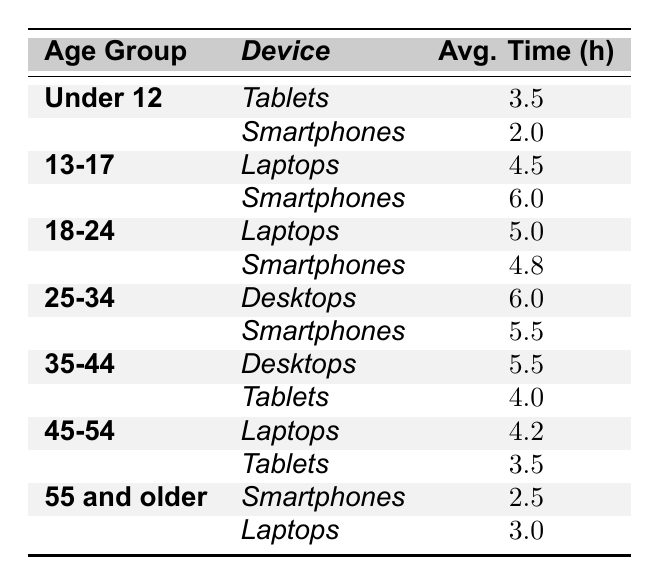What is the average daily screen time for users aged 25-34 using smartphones? The table lists the average daily screen time for the age group 25-34 using smartphones as 5.5 hours.
Answer: 5.5 Which age group has the highest average daily screen time using laptops? According to the table, the age group of 13-17 has the highest average daily screen time using laptops at 4.5 hours.
Answer: 4.5 What is the total average daily screen time for the age group 55 and older across all devices? Adding the values from the 55 and older age group: 2.5 hours (smartphones) + 3.0 hours (laptops) = 5.5 hours.
Answer: 5.5 Is the average daily screen time for tablets among users aged 45-54 greater than that for smartphones? The average daily screen time for tablets among users aged 45-54 is 3.5 hours, while smartphones are not listed for that age group, making this comparison not applicable or undetermined.
Answer: No What is the difference in average daily screen time between the age groups 13-17 and 18-24 for smartphones? The average time for 13-17 using smartphones is 6.0 hours, and for 18-24, it is 4.8 hours. The difference is 6.0 - 4.8 = 1.2 hours.
Answer: 1.2 Which age group uses desktops more, 25-34 or 35-44? The table shows that both age groups use desktops equally at 6.0 hours for 25-34 and 5.5 hours for 35-44, meaning 25-34 uses desktops more.
Answer: 25-34 What is the average daily screen time for all devices combined for age group Under 12? The average for Under 12: 3.5 hours (tablets) + 2.0 hours (smartphones) = 5.5 hours total. So, the average combined time is 5.5 hours.
Answer: 5.5 Is the average daily screen time for smartphones higher in the 35-44 age group than in the 55 and older age group? The average screen time for 35-44 using smartphones is not listed, while for 55 and older it is 2.5 hours. Since we cannot compare directly, we say false.
Answer: No Which device do users aged 18-24 spend more time on, laptops or smartphones? Users aged 18-24 spend 5.0 hours on laptops and 4.8 hours on smartphones, so they spend more time on laptops.
Answer: Laptops What is the average daily screen time for age group 45-54 when using tablets? The average daily screen time for age group 45-54 when using tablets is 3.5 hours according to the table.
Answer: 3.5 